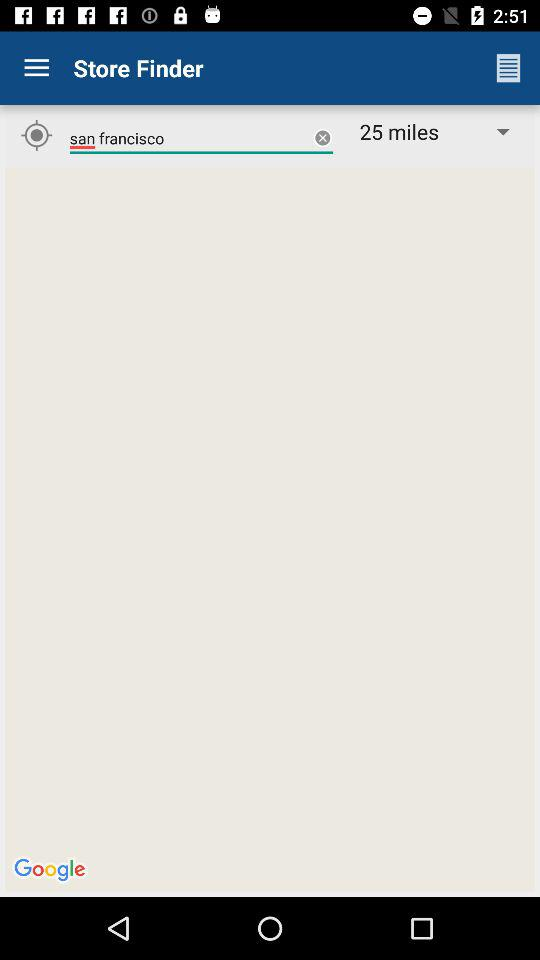What is the name of the application? The name of the application is "Store Finder". 